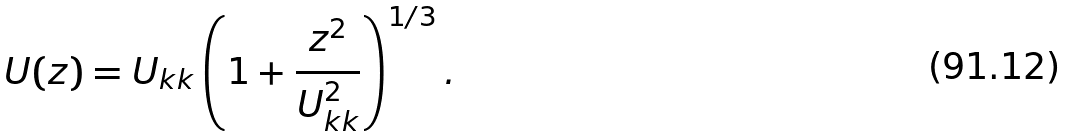<formula> <loc_0><loc_0><loc_500><loc_500>U ( z ) = U _ { k k } \left ( 1 + \frac { z ^ { 2 } } { U _ { k k } ^ { 2 } } \right ) ^ { 1 / 3 } .</formula> 